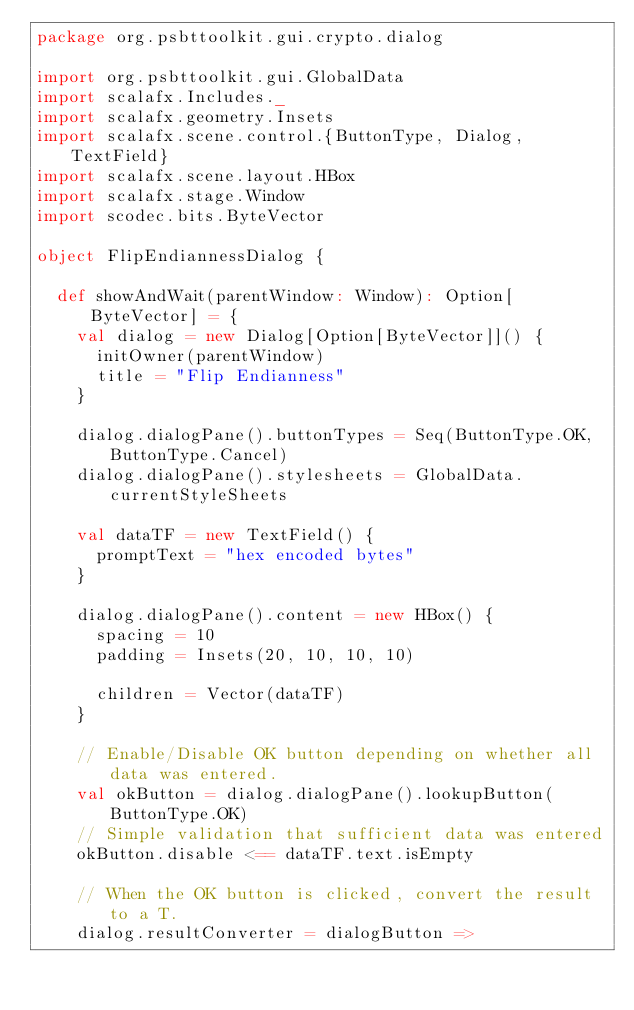<code> <loc_0><loc_0><loc_500><loc_500><_Scala_>package org.psbttoolkit.gui.crypto.dialog

import org.psbttoolkit.gui.GlobalData
import scalafx.Includes._
import scalafx.geometry.Insets
import scalafx.scene.control.{ButtonType, Dialog, TextField}
import scalafx.scene.layout.HBox
import scalafx.stage.Window
import scodec.bits.ByteVector

object FlipEndiannessDialog {

  def showAndWait(parentWindow: Window): Option[ByteVector] = {
    val dialog = new Dialog[Option[ByteVector]]() {
      initOwner(parentWindow)
      title = "Flip Endianness"
    }

    dialog.dialogPane().buttonTypes = Seq(ButtonType.OK, ButtonType.Cancel)
    dialog.dialogPane().stylesheets = GlobalData.currentStyleSheets

    val dataTF = new TextField() {
      promptText = "hex encoded bytes"
    }

    dialog.dialogPane().content = new HBox() {
      spacing = 10
      padding = Insets(20, 10, 10, 10)

      children = Vector(dataTF)
    }

    // Enable/Disable OK button depending on whether all data was entered.
    val okButton = dialog.dialogPane().lookupButton(ButtonType.OK)
    // Simple validation that sufficient data was entered
    okButton.disable <== dataTF.text.isEmpty

    // When the OK button is clicked, convert the result to a T.
    dialog.resultConverter = dialogButton =></code> 